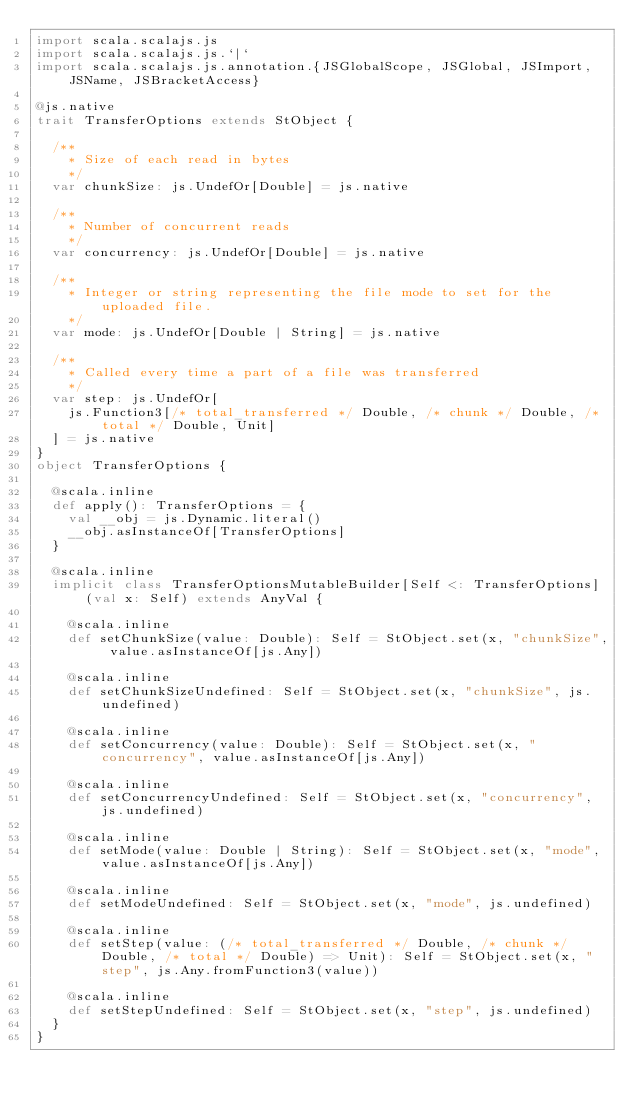Convert code to text. <code><loc_0><loc_0><loc_500><loc_500><_Scala_>import scala.scalajs.js
import scala.scalajs.js.`|`
import scala.scalajs.js.annotation.{JSGlobalScope, JSGlobal, JSImport, JSName, JSBracketAccess}

@js.native
trait TransferOptions extends StObject {
  
  /**
    * Size of each read in bytes
    */
  var chunkSize: js.UndefOr[Double] = js.native
  
  /**
    * Number of concurrent reads
    */
  var concurrency: js.UndefOr[Double] = js.native
  
  /**
    * Integer or string representing the file mode to set for the uploaded file.
    */
  var mode: js.UndefOr[Double | String] = js.native
  
  /**
    * Called every time a part of a file was transferred
    */
  var step: js.UndefOr[
    js.Function3[/* total_transferred */ Double, /* chunk */ Double, /* total */ Double, Unit]
  ] = js.native
}
object TransferOptions {
  
  @scala.inline
  def apply(): TransferOptions = {
    val __obj = js.Dynamic.literal()
    __obj.asInstanceOf[TransferOptions]
  }
  
  @scala.inline
  implicit class TransferOptionsMutableBuilder[Self <: TransferOptions] (val x: Self) extends AnyVal {
    
    @scala.inline
    def setChunkSize(value: Double): Self = StObject.set(x, "chunkSize", value.asInstanceOf[js.Any])
    
    @scala.inline
    def setChunkSizeUndefined: Self = StObject.set(x, "chunkSize", js.undefined)
    
    @scala.inline
    def setConcurrency(value: Double): Self = StObject.set(x, "concurrency", value.asInstanceOf[js.Any])
    
    @scala.inline
    def setConcurrencyUndefined: Self = StObject.set(x, "concurrency", js.undefined)
    
    @scala.inline
    def setMode(value: Double | String): Self = StObject.set(x, "mode", value.asInstanceOf[js.Any])
    
    @scala.inline
    def setModeUndefined: Self = StObject.set(x, "mode", js.undefined)
    
    @scala.inline
    def setStep(value: (/* total_transferred */ Double, /* chunk */ Double, /* total */ Double) => Unit): Self = StObject.set(x, "step", js.Any.fromFunction3(value))
    
    @scala.inline
    def setStepUndefined: Self = StObject.set(x, "step", js.undefined)
  }
}
</code> 